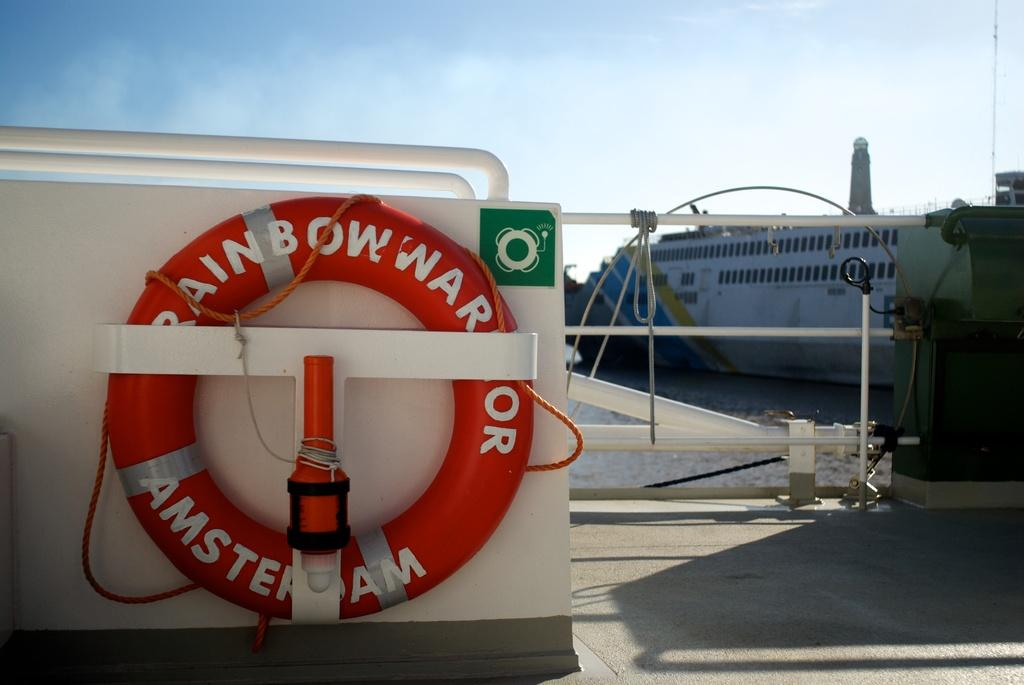Provide a one-sentence caption for the provided image. I boat with a life saver ring labeled Rainbow War Amsterdam. 